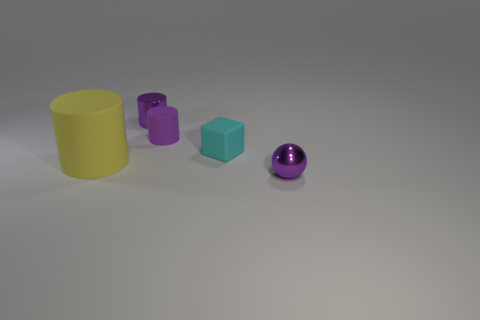Add 4 small cubes. How many objects exist? 9 Subtract all cylinders. How many objects are left? 2 Subtract 1 purple spheres. How many objects are left? 4 Subtract all cubes. Subtract all small cyan things. How many objects are left? 3 Add 1 small matte cubes. How many small matte cubes are left? 2 Add 3 large blue rubber spheres. How many large blue rubber spheres exist? 3 